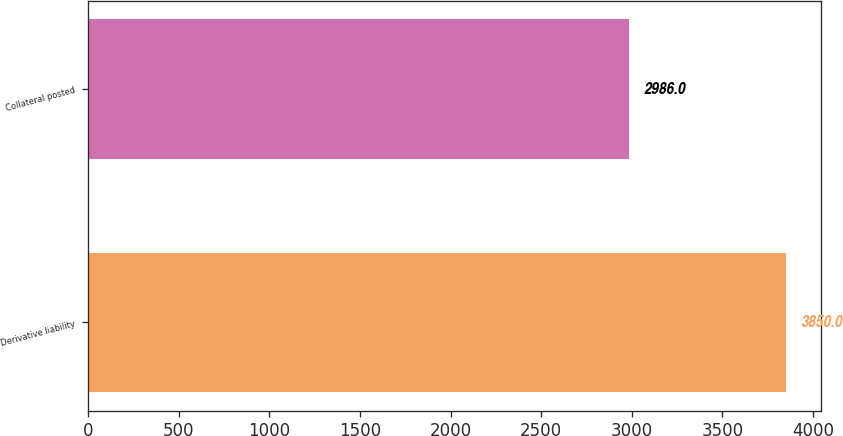<chart> <loc_0><loc_0><loc_500><loc_500><bar_chart><fcel>Derivative liability<fcel>Collateral posted<nl><fcel>3850<fcel>2986<nl></chart> 